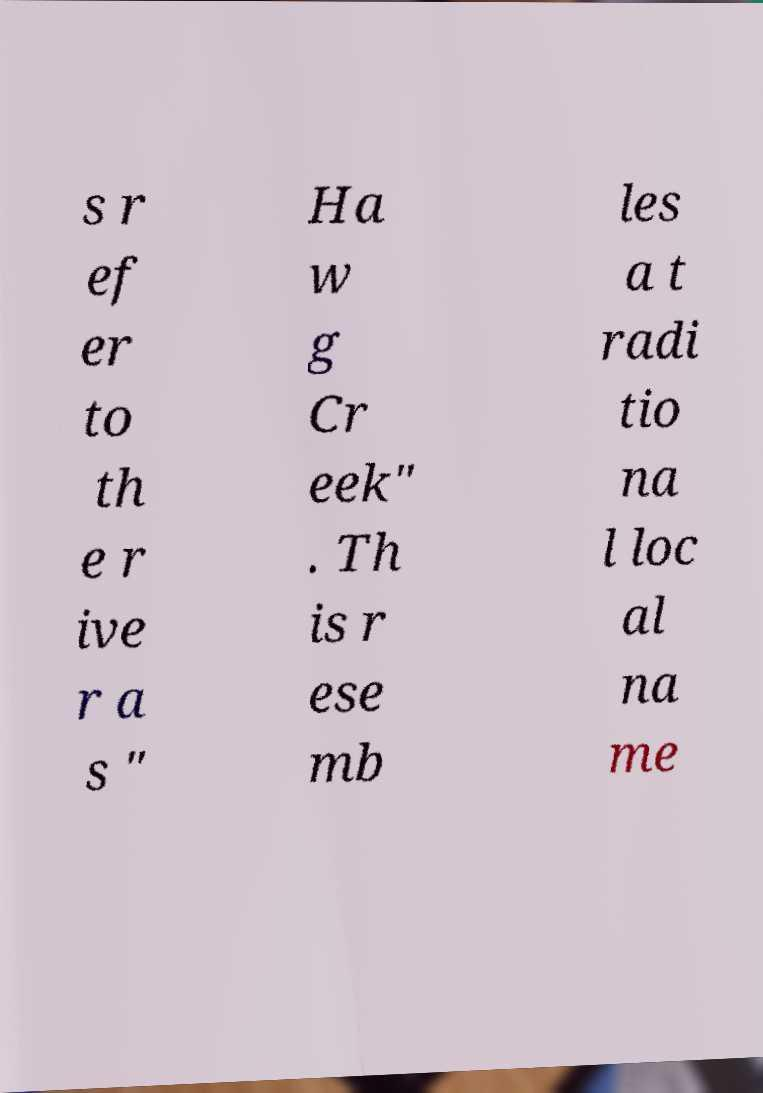Please read and relay the text visible in this image. What does it say? s r ef er to th e r ive r a s " Ha w g Cr eek" . Th is r ese mb les a t radi tio na l loc al na me 